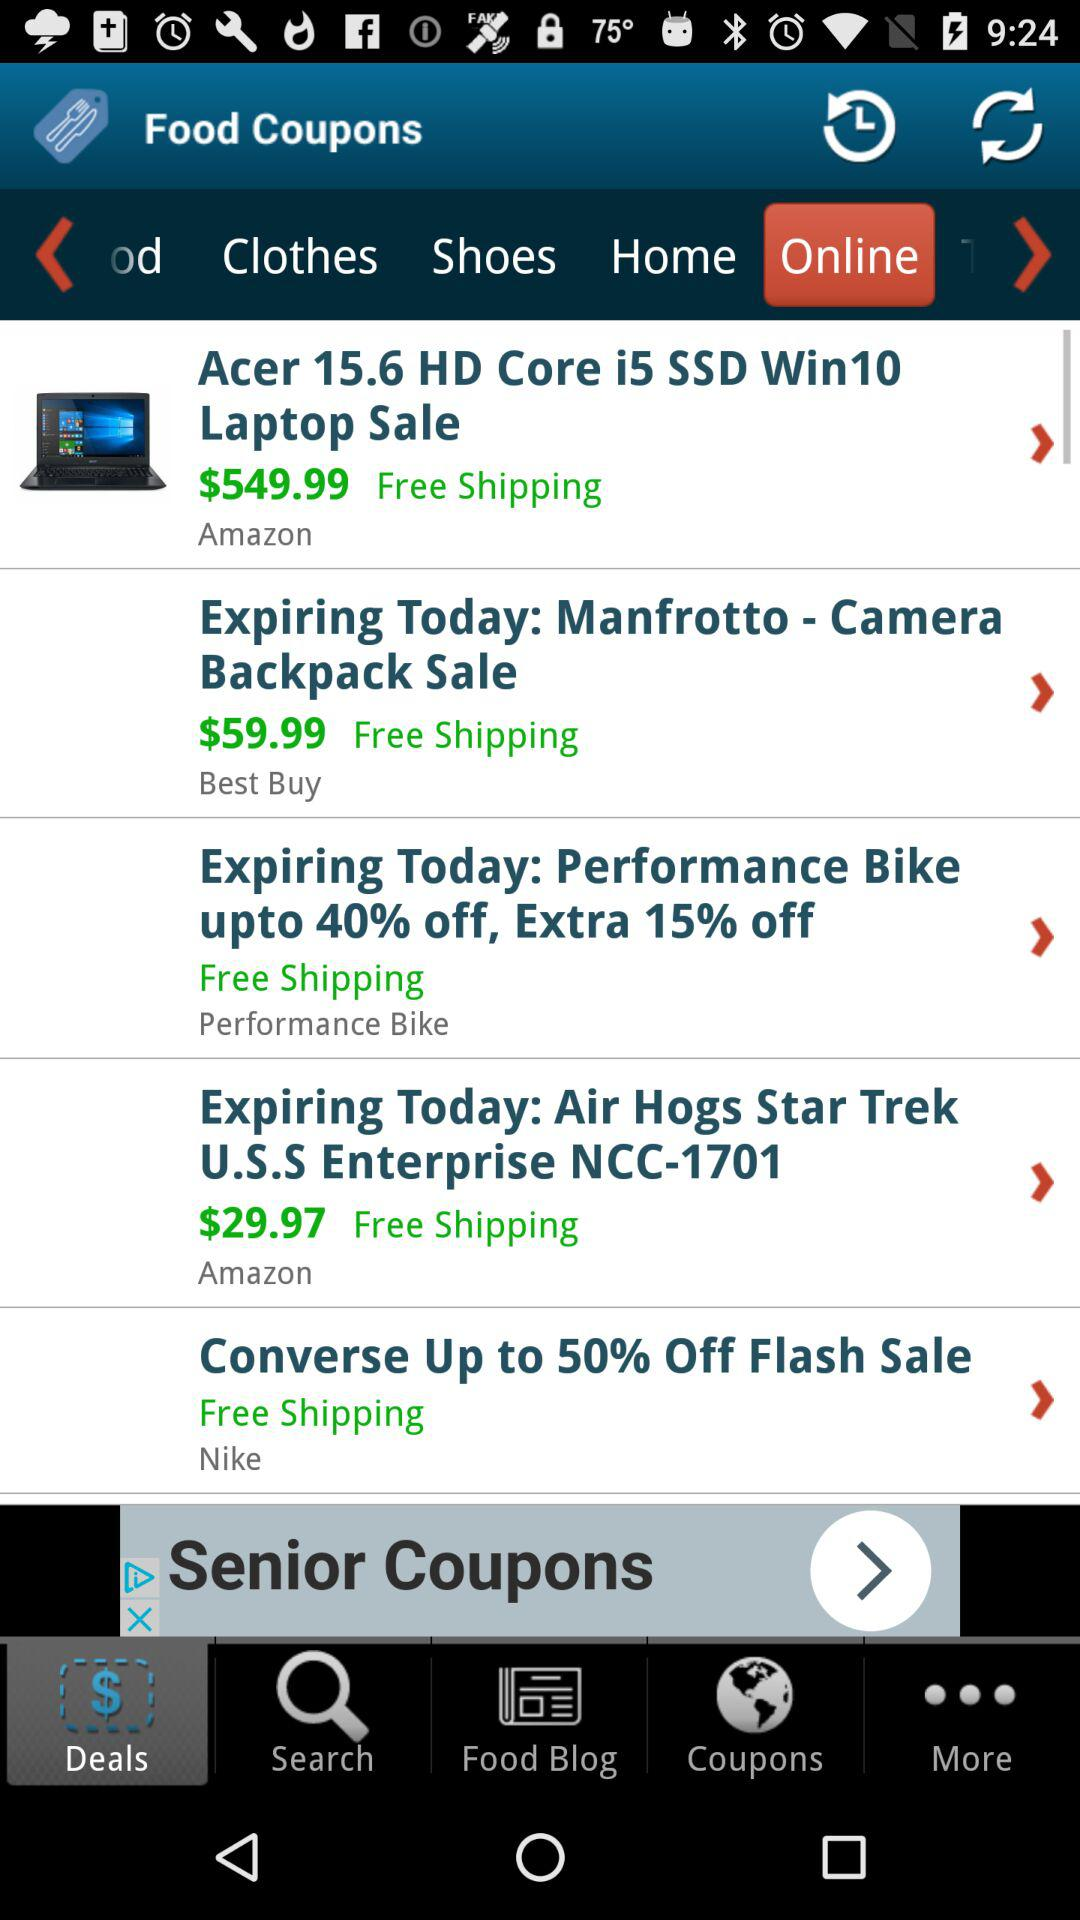Is shipping free or paid?
Answer the question using a single word or phrase. Shipping is free. 